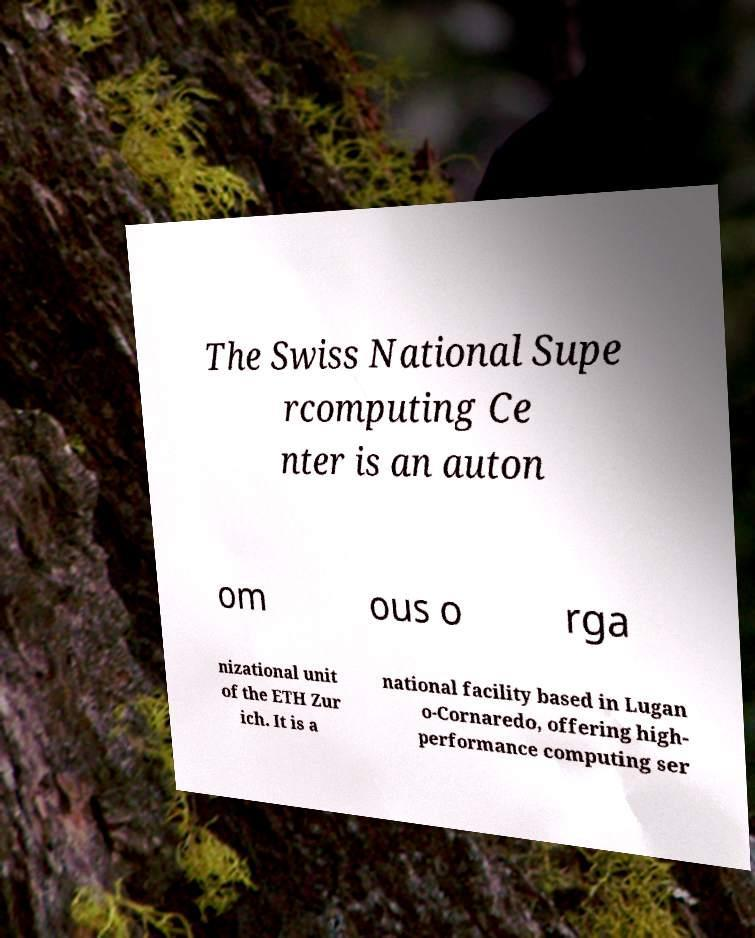For documentation purposes, I need the text within this image transcribed. Could you provide that? The Swiss National Supe rcomputing Ce nter is an auton om ous o rga nizational unit of the ETH Zur ich. It is a national facility based in Lugan o-Cornaredo, offering high- performance computing ser 